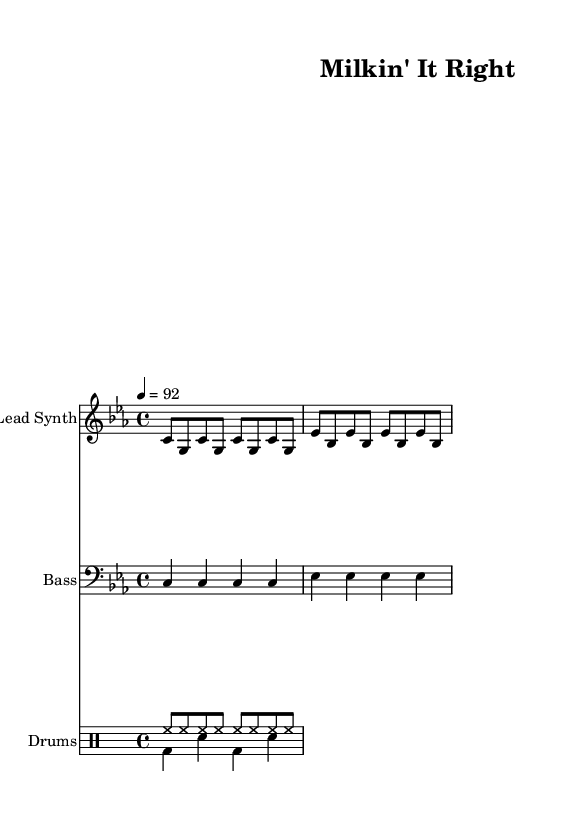What is the time signature of this music? The time signature is indicated at the beginning of the music as 4/4. This means there are four beats in each measure and the quarter note gets one beat.
Answer: 4/4 What is the key signature of this music? The key signature is C minor, which is indicated at the beginning of the piece. C minor has three flats: B flat, E flat, and A flat.
Answer: C minor What is the tempo of this music? The tempo is noted as 4 equals 92. This means there are 92 beats per minute, which is a moderate tempo typically associated with hip-hop music.
Answer: 92 How many measures are in the lead synth part? The lead synth part consists of two lines, each with four measures, totaling eight measures. Counting the measures per line gives us the total.
Answer: 8 Which instrument is playing the bass line? The bass line is indicated in the staff labeled "Bass." This is where the pitches for the bass part are written, specifically indicating the instrument utilized.
Answer: Bass What do the lyrics suggest about animal welfare? The lyrics state, “Keep the cows healthy, day and night,” which suggests an emphasis on the health and welfare of cows, aligning with ethical farming practices.
Answer: Welfare What genre does this piece of music belong to? The piece is designed with elements typical of hip-hop, such as the rhythmic drum patterns and the lyrical emphasis on social issues, specifically animal welfare.
Answer: Hip-hop 